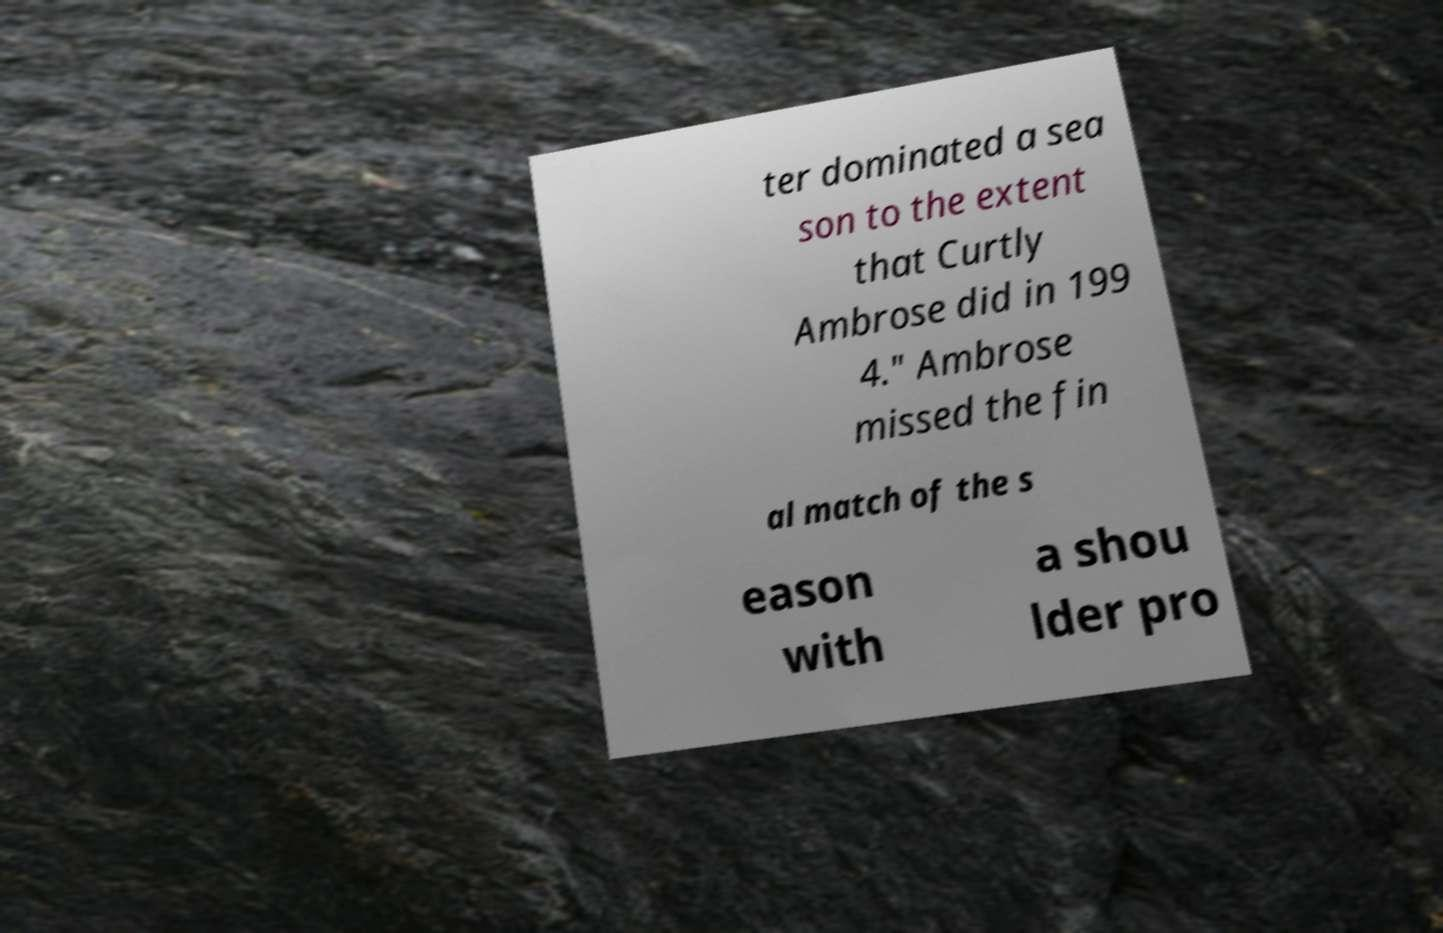Can you accurately transcribe the text from the provided image for me? ter dominated a sea son to the extent that Curtly Ambrose did in 199 4." Ambrose missed the fin al match of the s eason with a shou lder pro 